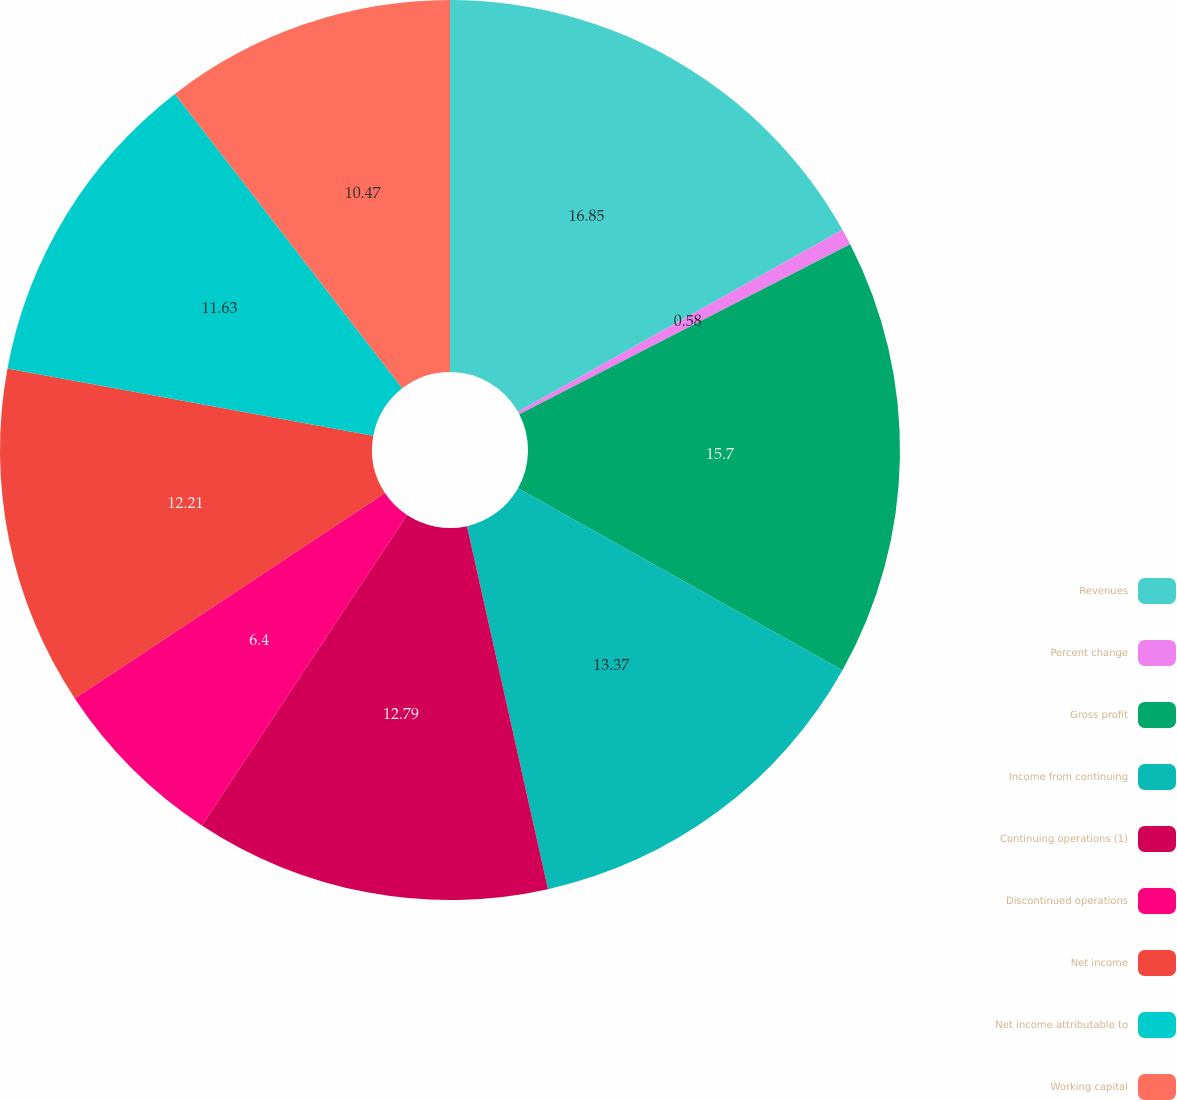<chart> <loc_0><loc_0><loc_500><loc_500><pie_chart><fcel>Revenues<fcel>Percent change<fcel>Gross profit<fcel>Income from continuing<fcel>Continuing operations (1)<fcel>Discontinued operations<fcel>Net income<fcel>Net income attributable to<fcel>Working capital<nl><fcel>16.86%<fcel>0.58%<fcel>15.7%<fcel>13.37%<fcel>12.79%<fcel>6.4%<fcel>12.21%<fcel>11.63%<fcel>10.47%<nl></chart> 